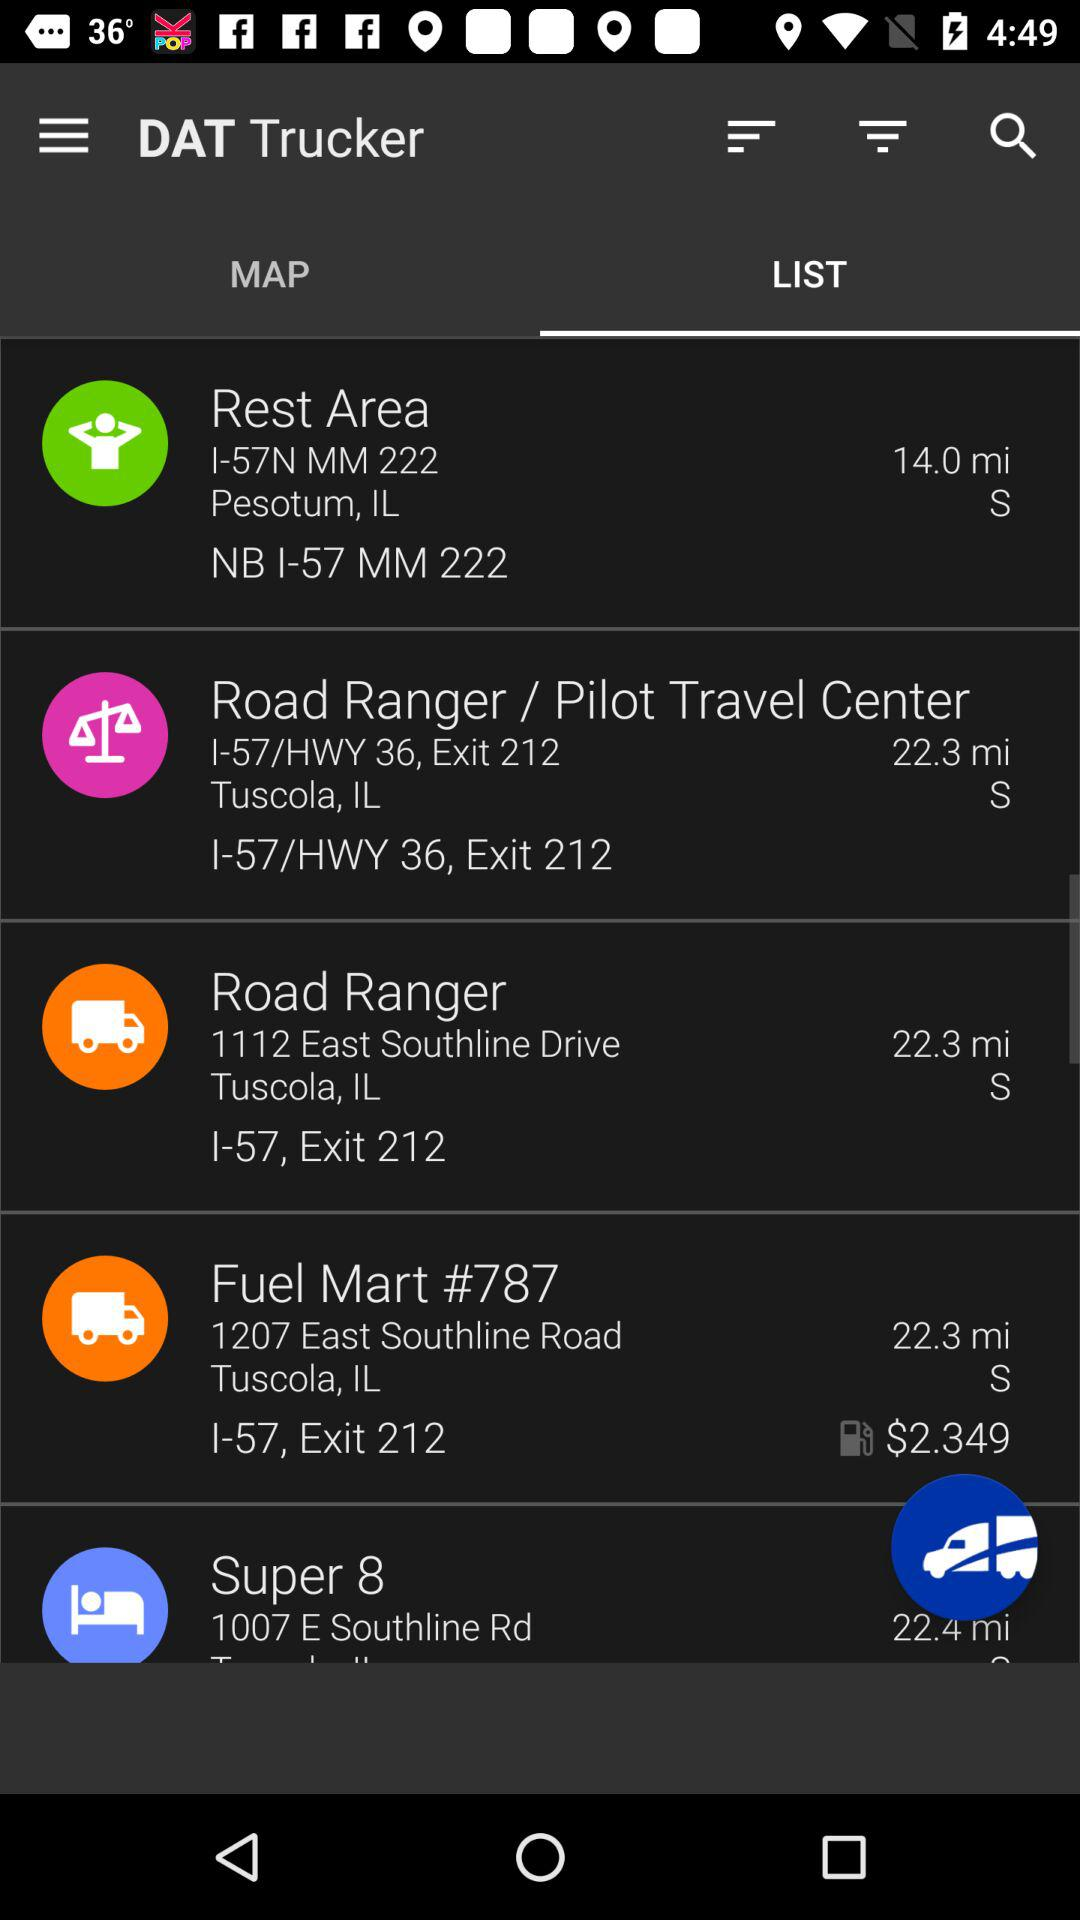Which tab is selected? The selected tab is "LIST". 